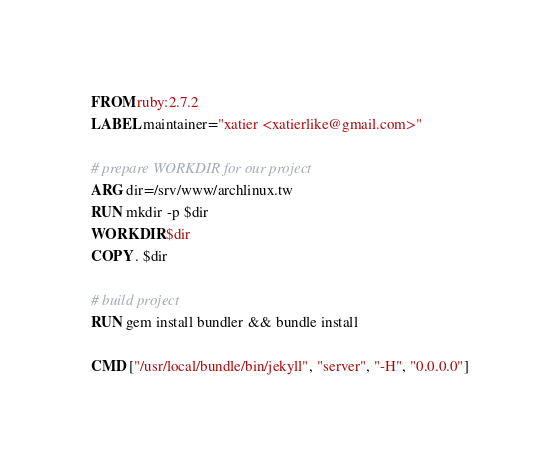<code> <loc_0><loc_0><loc_500><loc_500><_Dockerfile_>FROM ruby:2.7.2
LABEL maintainer="xatier <xatierlike@gmail.com>"

# prepare WORKDIR for our project
ARG dir=/srv/www/archlinux.tw
RUN mkdir -p $dir
WORKDIR $dir
COPY . $dir

# build project
RUN gem install bundler && bundle install

CMD ["/usr/local/bundle/bin/jekyll", "server", "-H", "0.0.0.0"]
</code> 